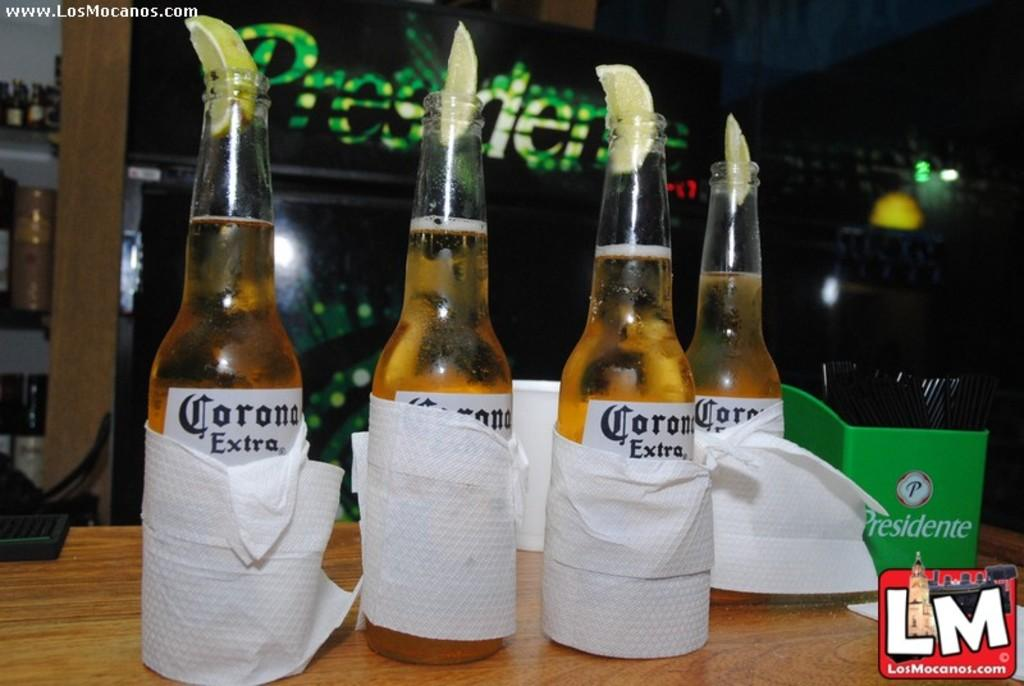<image>
Create a compact narrative representing the image presented. bottles of Corona Extra beer with lime wedges on a table 